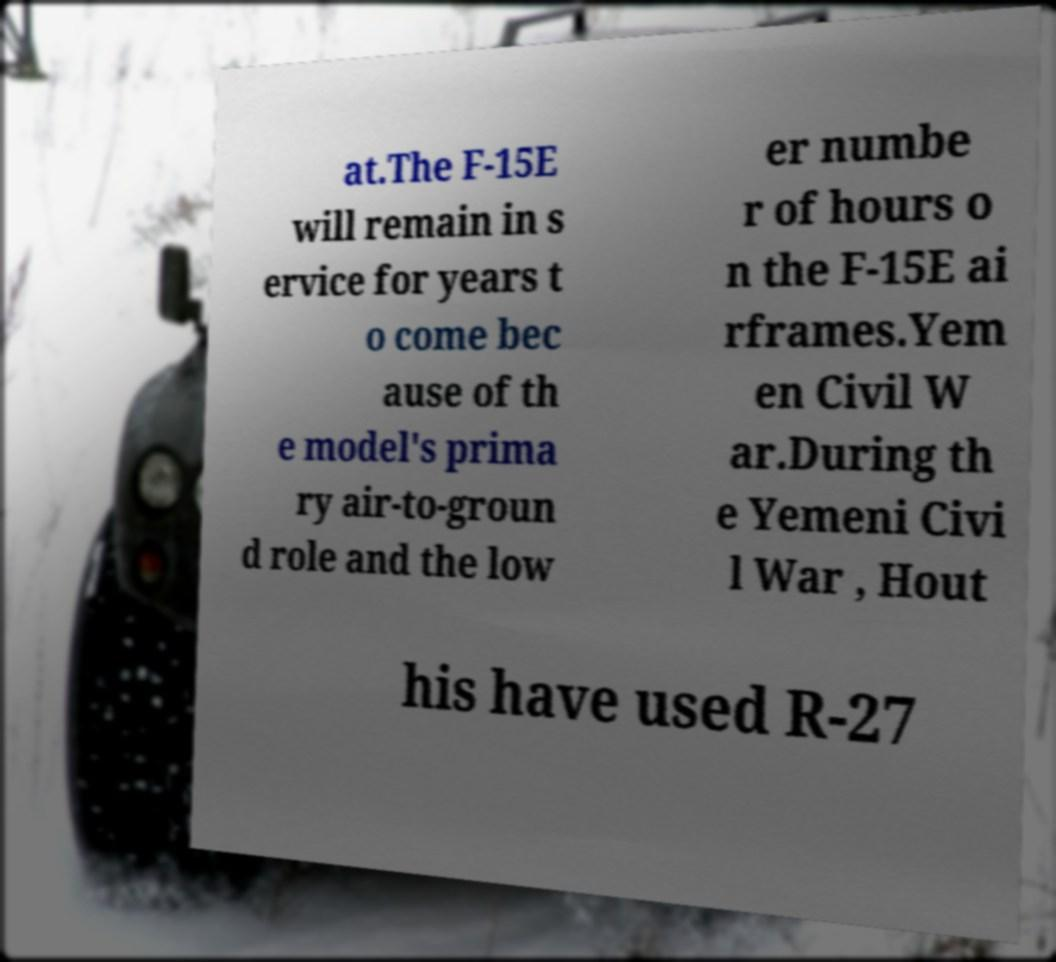I need the written content from this picture converted into text. Can you do that? at.The F-15E will remain in s ervice for years t o come bec ause of th e model's prima ry air-to-groun d role and the low er numbe r of hours o n the F-15E ai rframes.Yem en Civil W ar.During th e Yemeni Civi l War , Hout his have used R-27 